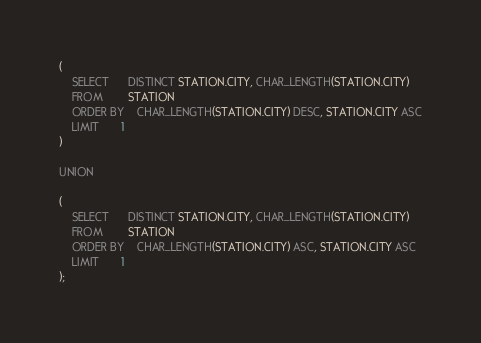<code> <loc_0><loc_0><loc_500><loc_500><_SQL_>(
    SELECT      DISTINCT STATION.CITY, CHAR_LENGTH(STATION.CITY)
    FROM        STATION
    ORDER BY    CHAR_LENGTH(STATION.CITY) DESC, STATION.CITY ASC
    LIMIT       1
)

UNION

(
    SELECT      DISTINCT STATION.CITY, CHAR_LENGTH(STATION.CITY)
    FROM        STATION
    ORDER BY    CHAR_LENGTH(STATION.CITY) ASC, STATION.CITY ASC
    LIMIT       1
);
</code> 